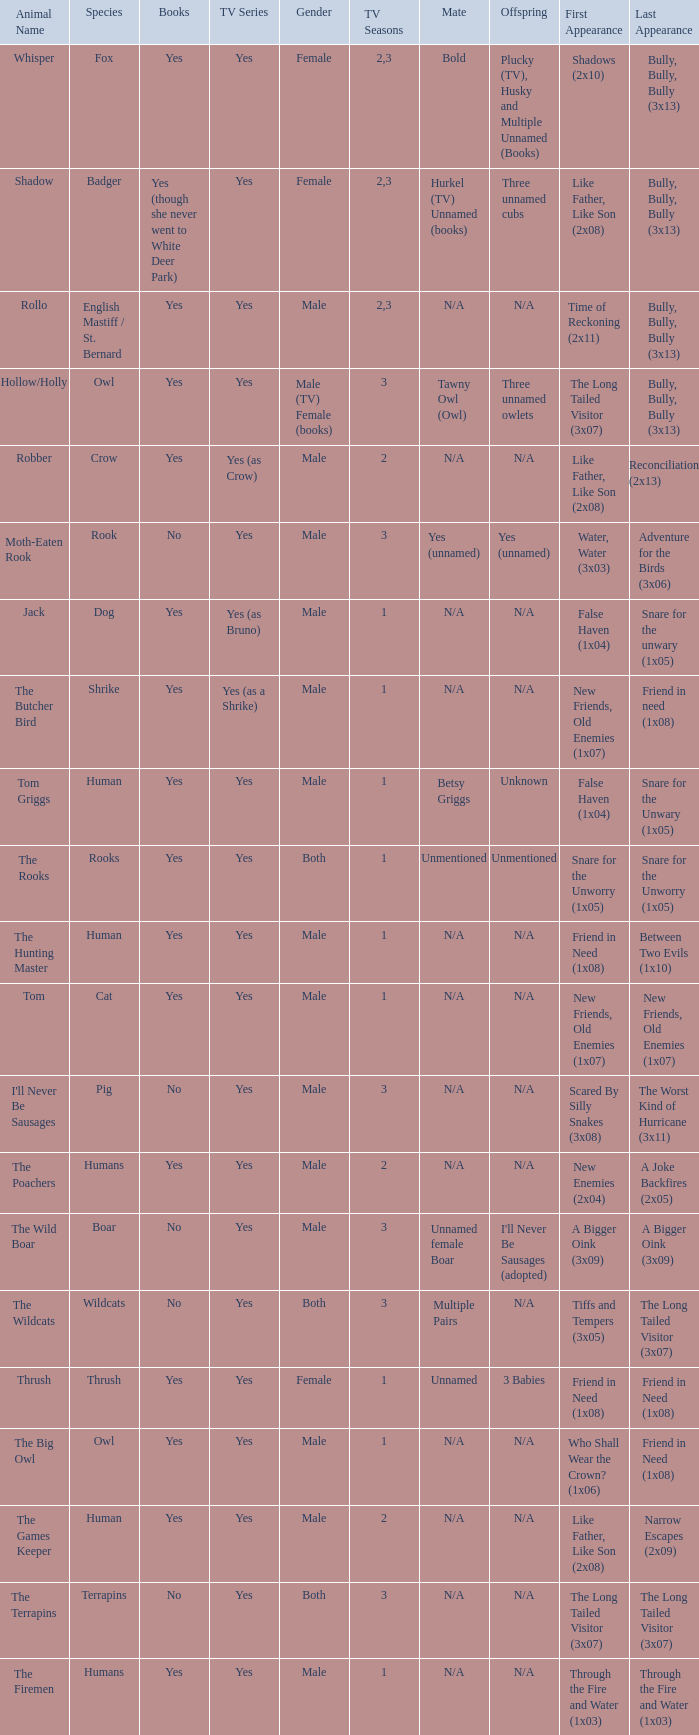Parse the full table. {'header': ['Animal Name', 'Species', 'Books', 'TV Series', 'Gender', 'TV Seasons', 'Mate', 'Offspring', 'First Appearance', 'Last Appearance'], 'rows': [['Whisper', 'Fox', 'Yes', 'Yes', 'Female', '2,3', 'Bold', 'Plucky (TV), Husky and Multiple Unnamed (Books)', 'Shadows (2x10)', 'Bully, Bully, Bully (3x13)'], ['Shadow', 'Badger', 'Yes (though she never went to White Deer Park)', 'Yes', 'Female', '2,3', 'Hurkel (TV) Unnamed (books)', 'Three unnamed cubs', 'Like Father, Like Son (2x08)', 'Bully, Bully, Bully (3x13)'], ['Rollo', 'English Mastiff / St. Bernard', 'Yes', 'Yes', 'Male', '2,3', 'N/A', 'N/A', 'Time of Reckoning (2x11)', 'Bully, Bully, Bully (3x13)'], ['Hollow/Holly', 'Owl', 'Yes', 'Yes', 'Male (TV) Female (books)', '3', 'Tawny Owl (Owl)', 'Three unnamed owlets', 'The Long Tailed Visitor (3x07)', 'Bully, Bully, Bully (3x13)'], ['Robber', 'Crow', 'Yes', 'Yes (as Crow)', 'Male', '2', 'N/A', 'N/A', 'Like Father, Like Son (2x08)', 'Reconciliation (2x13)'], ['Moth-Eaten Rook', 'Rook', 'No', 'Yes', 'Male', '3', 'Yes (unnamed)', 'Yes (unnamed)', 'Water, Water (3x03)', 'Adventure for the Birds (3x06)'], ['Jack', 'Dog', 'Yes', 'Yes (as Bruno)', 'Male', '1', 'N/A', 'N/A', 'False Haven (1x04)', 'Snare for the unwary (1x05)'], ['The Butcher Bird', 'Shrike', 'Yes', 'Yes (as a Shrike)', 'Male', '1', 'N/A', 'N/A', 'New Friends, Old Enemies (1x07)', 'Friend in need (1x08)'], ['Tom Griggs', 'Human', 'Yes', 'Yes', 'Male', '1', 'Betsy Griggs', 'Unknown', 'False Haven (1x04)', 'Snare for the Unwary (1x05)'], ['The Rooks', 'Rooks', 'Yes', 'Yes', 'Both', '1', 'Unmentioned', 'Unmentioned', 'Snare for the Unworry (1x05)', 'Snare for the Unworry (1x05)'], ['The Hunting Master', 'Human', 'Yes', 'Yes', 'Male', '1', 'N/A', 'N/A', 'Friend in Need (1x08)', 'Between Two Evils (1x10)'], ['Tom', 'Cat', 'Yes', 'Yes', 'Male', '1', 'N/A', 'N/A', 'New Friends, Old Enemies (1x07)', 'New Friends, Old Enemies (1x07)'], ["I'll Never Be Sausages", 'Pig', 'No', 'Yes', 'Male', '3', 'N/A', 'N/A', 'Scared By Silly Snakes (3x08)', 'The Worst Kind of Hurricane (3x11)'], ['The Poachers', 'Humans', 'Yes', 'Yes', 'Male', '2', 'N/A', 'N/A', 'New Enemies (2x04)', 'A Joke Backfires (2x05)'], ['The Wild Boar', 'Boar', 'No', 'Yes', 'Male', '3', 'Unnamed female Boar', "I'll Never Be Sausages (adopted)", 'A Bigger Oink (3x09)', 'A Bigger Oink (3x09)'], ['The Wildcats', 'Wildcats', 'No', 'Yes', 'Both', '3', 'Multiple Pairs', 'N/A', 'Tiffs and Tempers (3x05)', 'The Long Tailed Visitor (3x07)'], ['Thrush', 'Thrush', 'Yes', 'Yes', 'Female', '1', 'Unnamed', '3 Babies', 'Friend in Need (1x08)', 'Friend in Need (1x08)'], ['The Big Owl', 'Owl', 'Yes', 'Yes', 'Male', '1', 'N/A', 'N/A', 'Who Shall Wear the Crown? (1x06)', 'Friend in Need (1x08)'], ['The Games Keeper', 'Human', 'Yes', 'Yes', 'Male', '2', 'N/A', 'N/A', 'Like Father, Like Son (2x08)', 'Narrow Escapes (2x09)'], ['The Terrapins', 'Terrapins', 'No', 'Yes', 'Both', '3', 'N/A', 'N/A', 'The Long Tailed Visitor (3x07)', 'The Long Tailed Visitor (3x07)'], ['The Firemen', 'Humans', 'Yes', 'Yes', 'Male', '1', 'N/A', 'N/A', 'Through the Fire and Water (1x03)', 'Through the Fire and Water (1x03)']]} What show has a boar? Yes. 